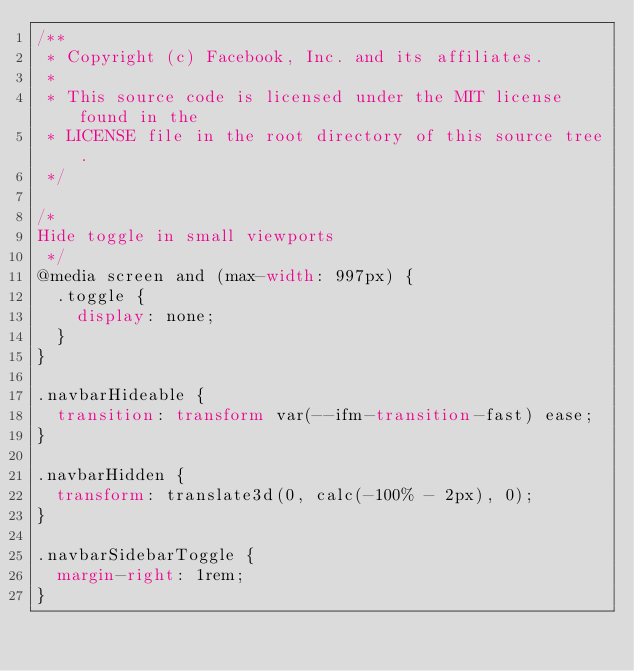Convert code to text. <code><loc_0><loc_0><loc_500><loc_500><_CSS_>/**
 * Copyright (c) Facebook, Inc. and its affiliates.
 *
 * This source code is licensed under the MIT license found in the
 * LICENSE file in the root directory of this source tree.
 */

/*
Hide toggle in small viewports
 */
@media screen and (max-width: 997px) {
  .toggle {
    display: none;
  }
}

.navbarHideable {
  transition: transform var(--ifm-transition-fast) ease;
}

.navbarHidden {
  transform: translate3d(0, calc(-100% - 2px), 0);
}

.navbarSidebarToggle {
  margin-right: 1rem;
}
</code> 